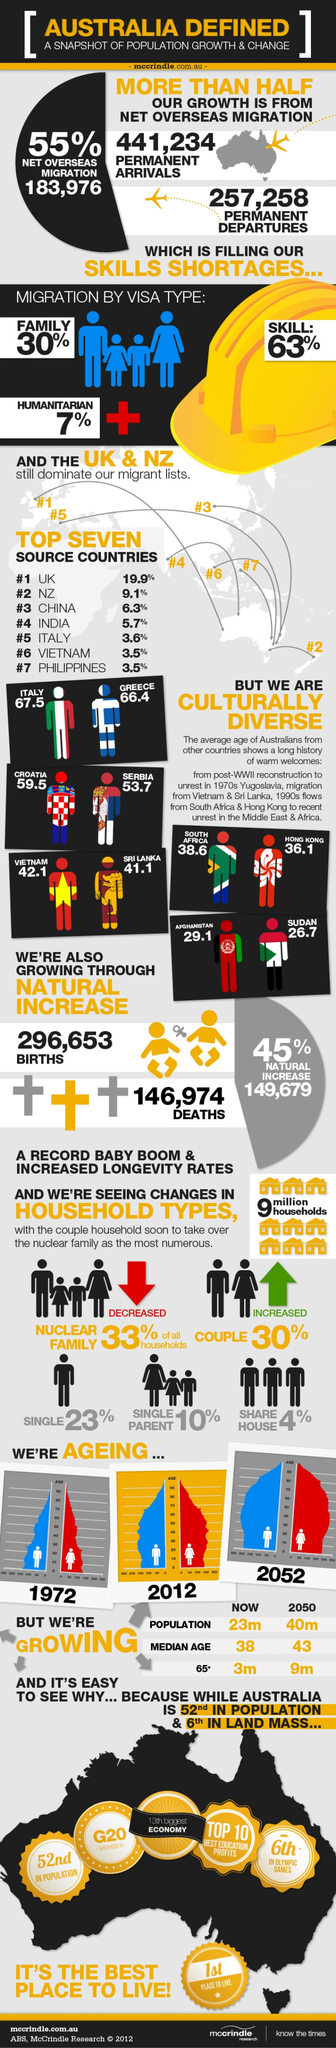Which visa type of migration is second highest?
Answer the question with a short phrase. family Which type of household has increased? couple Which is higher in number - permanent arrivals or permanent departures? permanent arrivals 63% of migrations are by which type of visa? skill Which year's graph shows lowest number of people above 80? 1972 